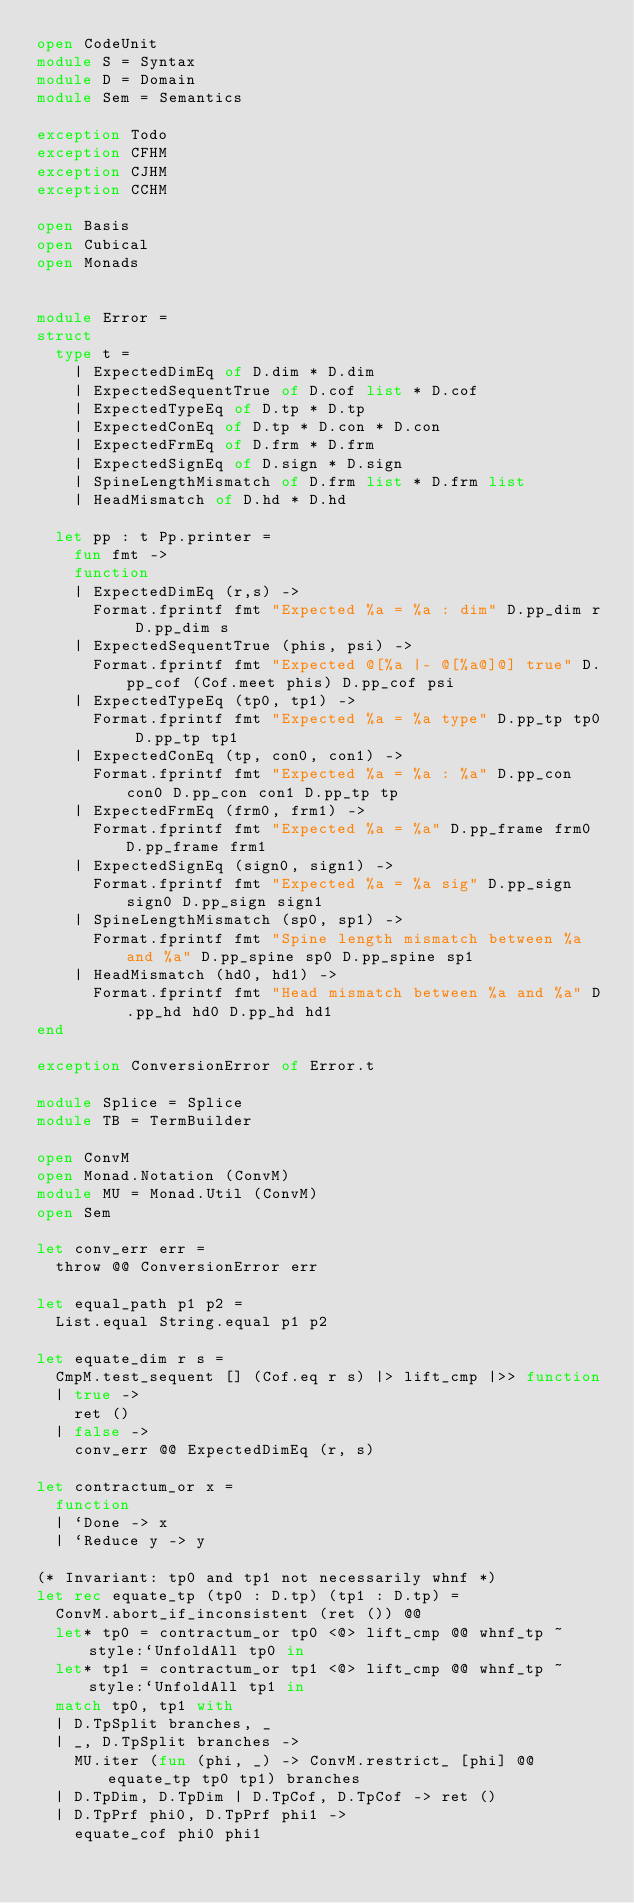Convert code to text. <code><loc_0><loc_0><loc_500><loc_500><_OCaml_>open CodeUnit
module S = Syntax
module D = Domain
module Sem = Semantics

exception Todo
exception CFHM
exception CJHM
exception CCHM

open Basis
open Cubical
open Monads


module Error =
struct
  type t =
    | ExpectedDimEq of D.dim * D.dim
    | ExpectedSequentTrue of D.cof list * D.cof
    | ExpectedTypeEq of D.tp * D.tp
    | ExpectedConEq of D.tp * D.con * D.con
    | ExpectedFrmEq of D.frm * D.frm
    | ExpectedSignEq of D.sign * D.sign
    | SpineLengthMismatch of D.frm list * D.frm list
    | HeadMismatch of D.hd * D.hd

  let pp : t Pp.printer =
    fun fmt ->
    function
    | ExpectedDimEq (r,s) ->
      Format.fprintf fmt "Expected %a = %a : dim" D.pp_dim r D.pp_dim s
    | ExpectedSequentTrue (phis, psi) ->
      Format.fprintf fmt "Expected @[%a |- @[%a@]@] true" D.pp_cof (Cof.meet phis) D.pp_cof psi
    | ExpectedTypeEq (tp0, tp1) ->
      Format.fprintf fmt "Expected %a = %a type" D.pp_tp tp0 D.pp_tp tp1
    | ExpectedConEq (tp, con0, con1) ->
      Format.fprintf fmt "Expected %a = %a : %a" D.pp_con con0 D.pp_con con1 D.pp_tp tp
    | ExpectedFrmEq (frm0, frm1) ->
      Format.fprintf fmt "Expected %a = %a" D.pp_frame frm0 D.pp_frame frm1
    | ExpectedSignEq (sign0, sign1) ->
      Format.fprintf fmt "Expected %a = %a sig" D.pp_sign sign0 D.pp_sign sign1
    | SpineLengthMismatch (sp0, sp1) ->
      Format.fprintf fmt "Spine length mismatch between %a and %a" D.pp_spine sp0 D.pp_spine sp1
    | HeadMismatch (hd0, hd1) ->
      Format.fprintf fmt "Head mismatch between %a and %a" D.pp_hd hd0 D.pp_hd hd1
end

exception ConversionError of Error.t

module Splice = Splice
module TB = TermBuilder

open ConvM
open Monad.Notation (ConvM)
module MU = Monad.Util (ConvM)
open Sem

let conv_err err =
  throw @@ ConversionError err

let equal_path p1 p2 =
  List.equal String.equal p1 p2

let equate_dim r s =
  CmpM.test_sequent [] (Cof.eq r s) |> lift_cmp |>> function
  | true ->
    ret ()
  | false ->
    conv_err @@ ExpectedDimEq (r, s)

let contractum_or x =
  function
  | `Done -> x
  | `Reduce y -> y

(* Invariant: tp0 and tp1 not necessarily whnf *)
let rec equate_tp (tp0 : D.tp) (tp1 : D.tp) =
  ConvM.abort_if_inconsistent (ret ()) @@
  let* tp0 = contractum_or tp0 <@> lift_cmp @@ whnf_tp ~style:`UnfoldAll tp0 in
  let* tp1 = contractum_or tp1 <@> lift_cmp @@ whnf_tp ~style:`UnfoldAll tp1 in
  match tp0, tp1 with
  | D.TpSplit branches, _
  | _, D.TpSplit branches ->
    MU.iter (fun (phi, _) -> ConvM.restrict_ [phi] @@ equate_tp tp0 tp1) branches
  | D.TpDim, D.TpDim | D.TpCof, D.TpCof -> ret ()
  | D.TpPrf phi0, D.TpPrf phi1 ->
    equate_cof phi0 phi1</code> 